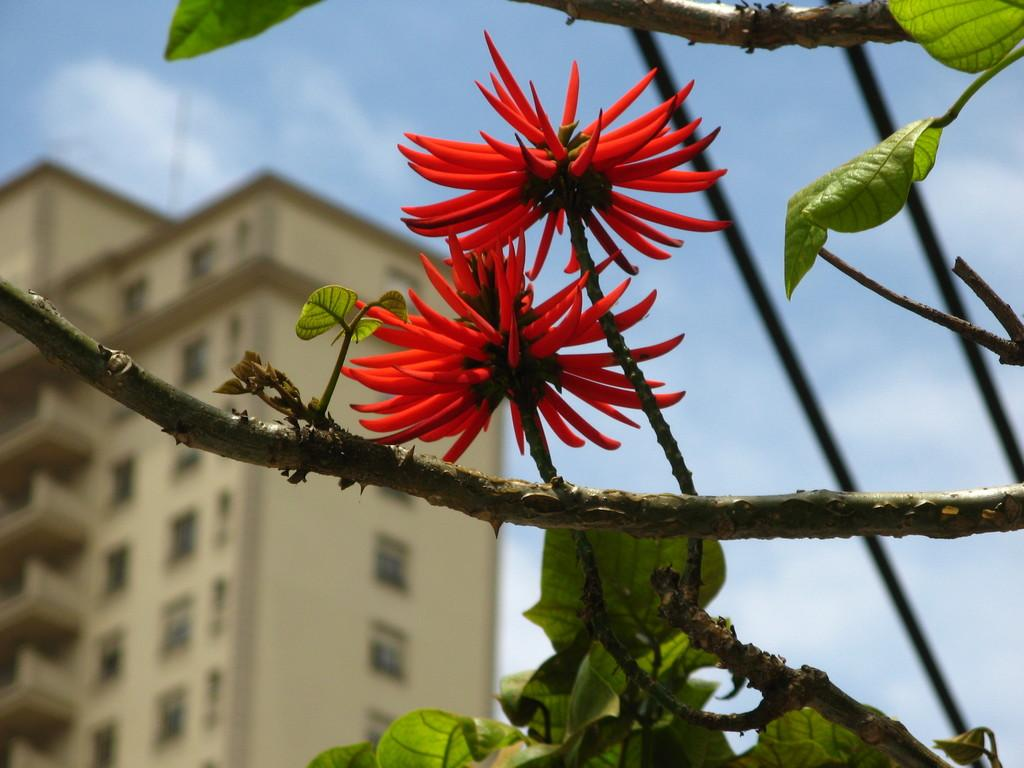What type of flowers can be seen in the image? There are two red color flowers in the image. What else is present in the image besides the flowers? There are leaves in the image. What can be seen in the background of the image? There is a building in the background of the image. What is visible at the top of the image? The sky is visible at the top of the image. Where is the playground located in the image? There is no playground present in the image. What type of cap is the flower wearing in the image? Flowers do not wear caps, as they are plants and not people. 